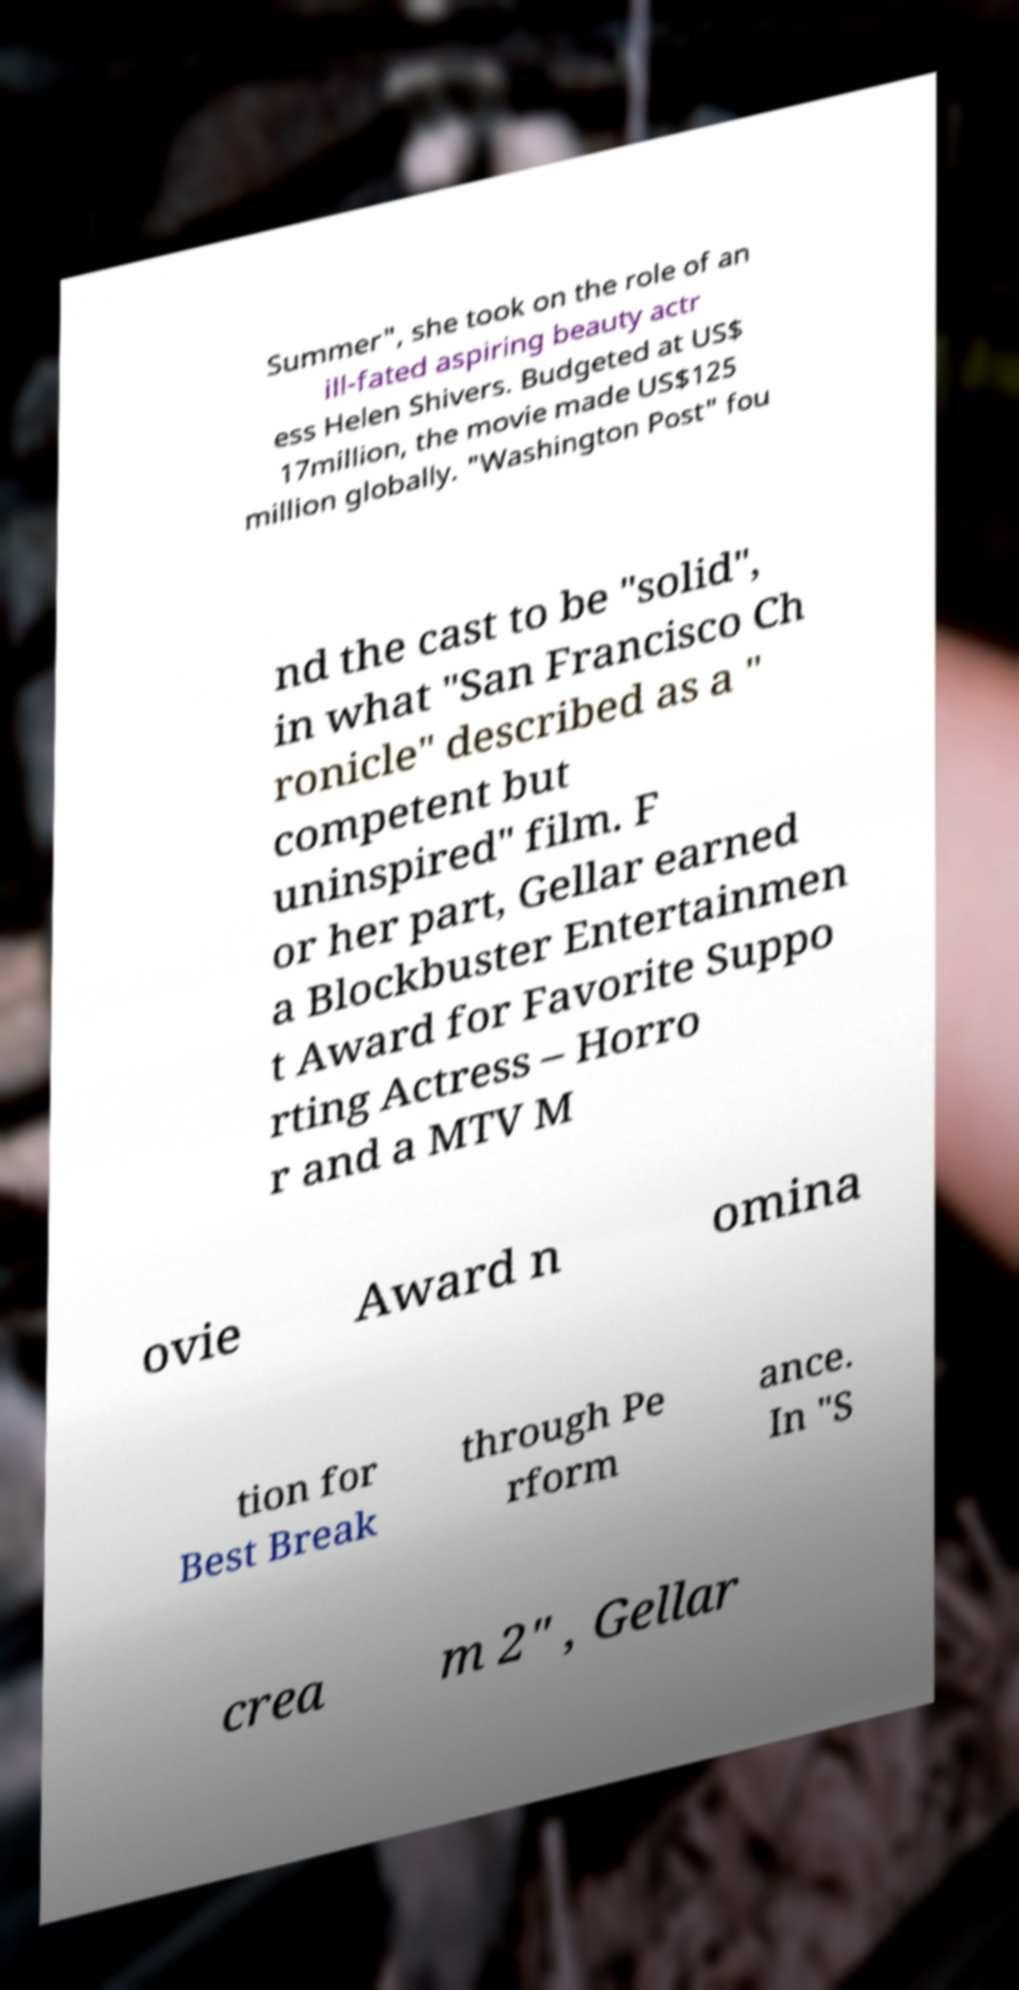There's text embedded in this image that I need extracted. Can you transcribe it verbatim? Summer", she took on the role of an ill-fated aspiring beauty actr ess Helen Shivers. Budgeted at US$ 17million, the movie made US$125 million globally. "Washington Post" fou nd the cast to be "solid", in what "San Francisco Ch ronicle" described as a " competent but uninspired" film. F or her part, Gellar earned a Blockbuster Entertainmen t Award for Favorite Suppo rting Actress – Horro r and a MTV M ovie Award n omina tion for Best Break through Pe rform ance. In "S crea m 2" , Gellar 